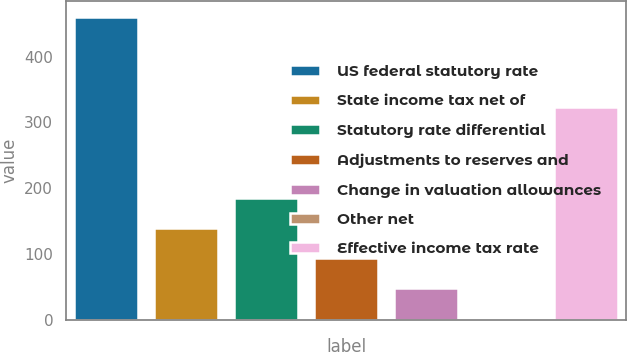<chart> <loc_0><loc_0><loc_500><loc_500><bar_chart><fcel>US federal statutory rate<fcel>State income tax net of<fcel>Statutory rate differential<fcel>Adjustments to reserves and<fcel>Change in valuation allowances<fcel>Other net<fcel>Effective income tax rate<nl><fcel>461<fcel>139.7<fcel>185.6<fcel>93.8<fcel>47.9<fcel>2<fcel>324<nl></chart> 